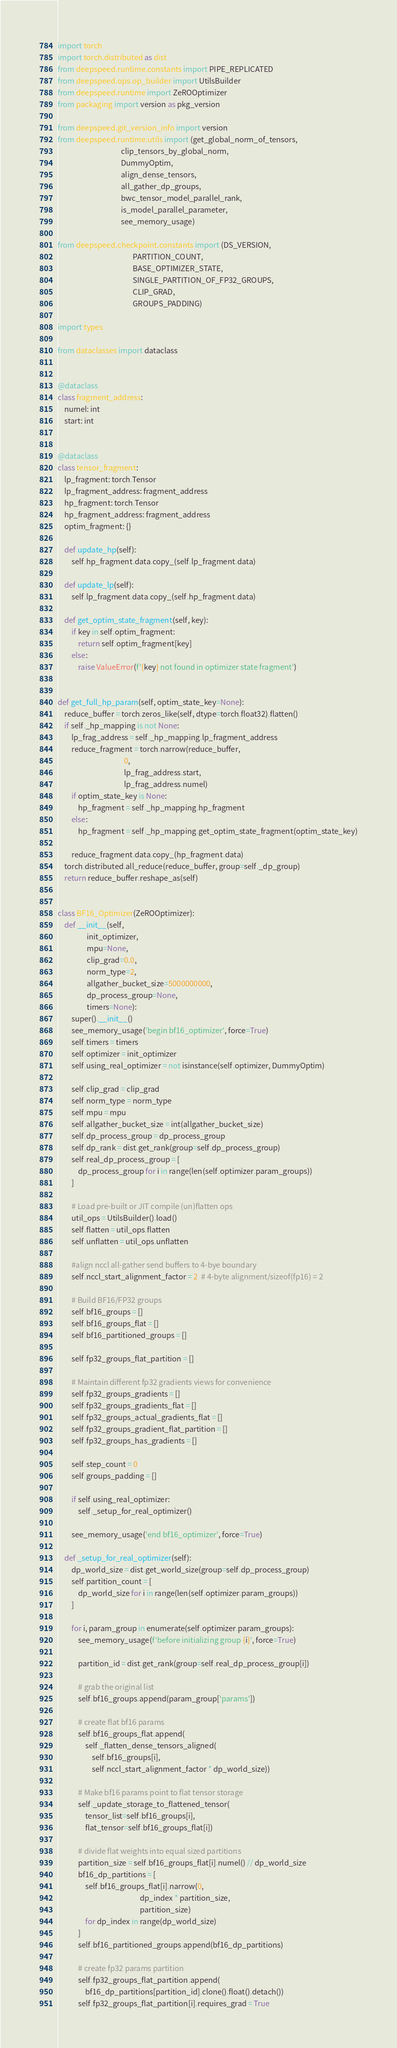<code> <loc_0><loc_0><loc_500><loc_500><_Python_>import torch
import torch.distributed as dist
from deepspeed.runtime.constants import PIPE_REPLICATED
from deepspeed.ops.op_builder import UtilsBuilder
from deepspeed.runtime import ZeROOptimizer
from packaging import version as pkg_version

from deepspeed.git_version_info import version
from deepspeed.runtime.utils import (get_global_norm_of_tensors,
                                     clip_tensors_by_global_norm,
                                     DummyOptim,
                                     align_dense_tensors,
                                     all_gather_dp_groups,
                                     bwc_tensor_model_parallel_rank,
                                     is_model_parallel_parameter,
                                     see_memory_usage)

from deepspeed.checkpoint.constants import (DS_VERSION,
                                            PARTITION_COUNT,
                                            BASE_OPTIMIZER_STATE,
                                            SINGLE_PARTITION_OF_FP32_GROUPS,
                                            CLIP_GRAD,
                                            GROUPS_PADDING)

import types

from dataclasses import dataclass


@dataclass
class fragment_address:
    numel: int
    start: int


@dataclass
class tensor_fragment:
    lp_fragment: torch.Tensor
    lp_fragment_address: fragment_address
    hp_fragment: torch.Tensor
    hp_fragment_address: fragment_address
    optim_fragment: {}

    def update_hp(self):
        self.hp_fragment.data.copy_(self.lp_fragment.data)

    def update_lp(self):
        self.lp_fragment.data.copy_(self.hp_fragment.data)

    def get_optim_state_fragment(self, key):
        if key in self.optim_fragment:
            return self.optim_fragment[key]
        else:
            raise ValueError(f'{key} not found in optimizer state fragment')


def get_full_hp_param(self, optim_state_key=None):
    reduce_buffer = torch.zeros_like(self, dtype=torch.float32).flatten()
    if self._hp_mapping is not None:
        lp_frag_address = self._hp_mapping.lp_fragment_address
        reduce_fragment = torch.narrow(reduce_buffer,
                                       0,
                                       lp_frag_address.start,
                                       lp_frag_address.numel)
        if optim_state_key is None:
            hp_fragment = self._hp_mapping.hp_fragment
        else:
            hp_fragment = self._hp_mapping.get_optim_state_fragment(optim_state_key)

        reduce_fragment.data.copy_(hp_fragment.data)
    torch.distributed.all_reduce(reduce_buffer, group=self._dp_group)
    return reduce_buffer.reshape_as(self)


class BF16_Optimizer(ZeROOptimizer):
    def __init__(self,
                 init_optimizer,
                 mpu=None,
                 clip_grad=0.0,
                 norm_type=2,
                 allgather_bucket_size=5000000000,
                 dp_process_group=None,
                 timers=None):
        super().__init__()
        see_memory_usage('begin bf16_optimizer', force=True)
        self.timers = timers
        self.optimizer = init_optimizer
        self.using_real_optimizer = not isinstance(self.optimizer, DummyOptim)

        self.clip_grad = clip_grad
        self.norm_type = norm_type
        self.mpu = mpu
        self.allgather_bucket_size = int(allgather_bucket_size)
        self.dp_process_group = dp_process_group
        self.dp_rank = dist.get_rank(group=self.dp_process_group)
        self.real_dp_process_group = [
            dp_process_group for i in range(len(self.optimizer.param_groups))
        ]

        # Load pre-built or JIT compile (un)flatten ops
        util_ops = UtilsBuilder().load()
        self.flatten = util_ops.flatten
        self.unflatten = util_ops.unflatten

        #align nccl all-gather send buffers to 4-bye boundary
        self.nccl_start_alignment_factor = 2  # 4-byte alignment/sizeof(fp16) = 2

        # Build BF16/FP32 groups
        self.bf16_groups = []
        self.bf16_groups_flat = []
        self.bf16_partitioned_groups = []

        self.fp32_groups_flat_partition = []

        # Maintain different fp32 gradients views for convenience
        self.fp32_groups_gradients = []
        self.fp32_groups_gradients_flat = []
        self.fp32_groups_actual_gradients_flat = []
        self.fp32_groups_gradient_flat_partition = []
        self.fp32_groups_has_gradients = []

        self.step_count = 0
        self.groups_padding = []

        if self.using_real_optimizer:
            self._setup_for_real_optimizer()

        see_memory_usage('end bf16_optimizer', force=True)

    def _setup_for_real_optimizer(self):
        dp_world_size = dist.get_world_size(group=self.dp_process_group)
        self.partition_count = [
            dp_world_size for i in range(len(self.optimizer.param_groups))
        ]

        for i, param_group in enumerate(self.optimizer.param_groups):
            see_memory_usage(f'before initializing group {i}', force=True)

            partition_id = dist.get_rank(group=self.real_dp_process_group[i])

            # grab the original list
            self.bf16_groups.append(param_group['params'])

            # create flat bf16 params
            self.bf16_groups_flat.append(
                self._flatten_dense_tensors_aligned(
                    self.bf16_groups[i],
                    self.nccl_start_alignment_factor * dp_world_size))

            # Make bf16 params point to flat tensor storage
            self._update_storage_to_flattened_tensor(
                tensor_list=self.bf16_groups[i],
                flat_tensor=self.bf16_groups_flat[i])

            # divide flat weights into equal sized partitions
            partition_size = self.bf16_groups_flat[i].numel() // dp_world_size
            bf16_dp_partitions = [
                self.bf16_groups_flat[i].narrow(0,
                                                dp_index * partition_size,
                                                partition_size)
                for dp_index in range(dp_world_size)
            ]
            self.bf16_partitioned_groups.append(bf16_dp_partitions)

            # create fp32 params partition
            self.fp32_groups_flat_partition.append(
                bf16_dp_partitions[partition_id].clone().float().detach())
            self.fp32_groups_flat_partition[i].requires_grad = True
</code> 